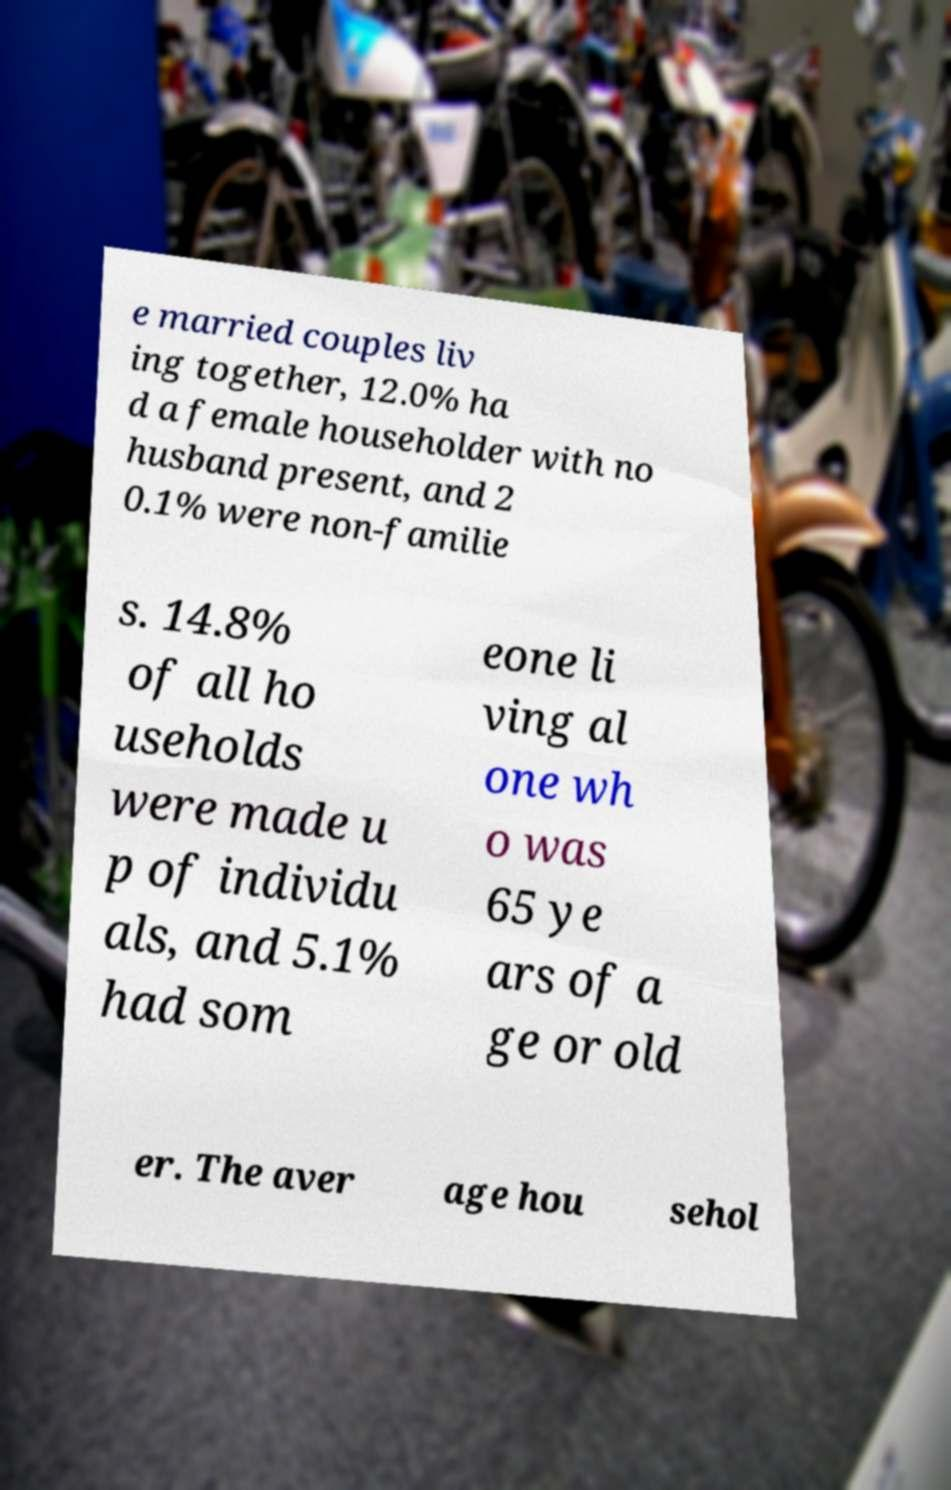Could you assist in decoding the text presented in this image and type it out clearly? e married couples liv ing together, 12.0% ha d a female householder with no husband present, and 2 0.1% were non-familie s. 14.8% of all ho useholds were made u p of individu als, and 5.1% had som eone li ving al one wh o was 65 ye ars of a ge or old er. The aver age hou sehol 